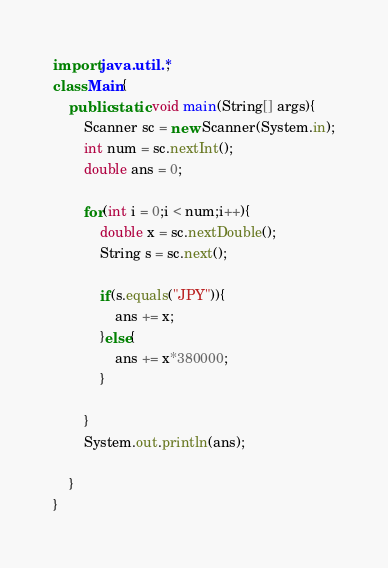Convert code to text. <code><loc_0><loc_0><loc_500><loc_500><_Java_>import java.util.*;
class Main{
    public static void main(String[] args){
        Scanner sc = new Scanner(System.in);
        int num = sc.nextInt();
        double ans = 0;

        for(int i = 0;i < num;i++){
            double x = sc.nextDouble();
            String s = sc.next();

            if(s.equals("JPY")){
                ans += x;
            }else{
                ans += x*380000;
            }

        }
        System.out.println(ans);
        
    }
}</code> 